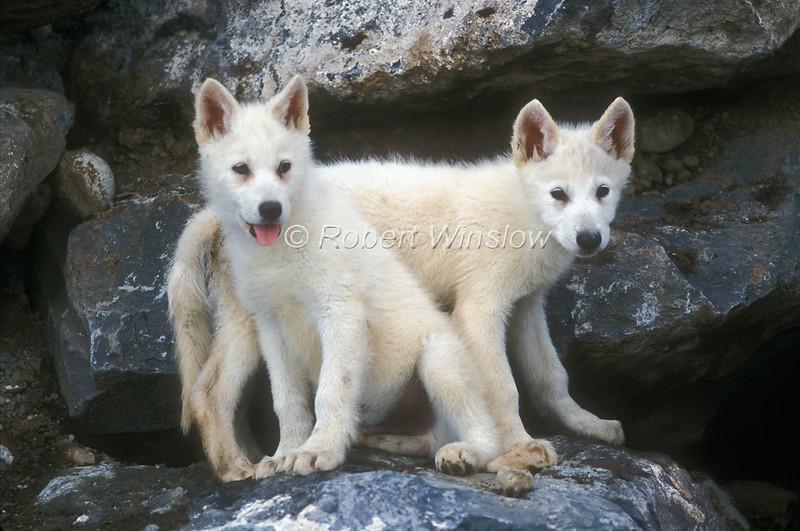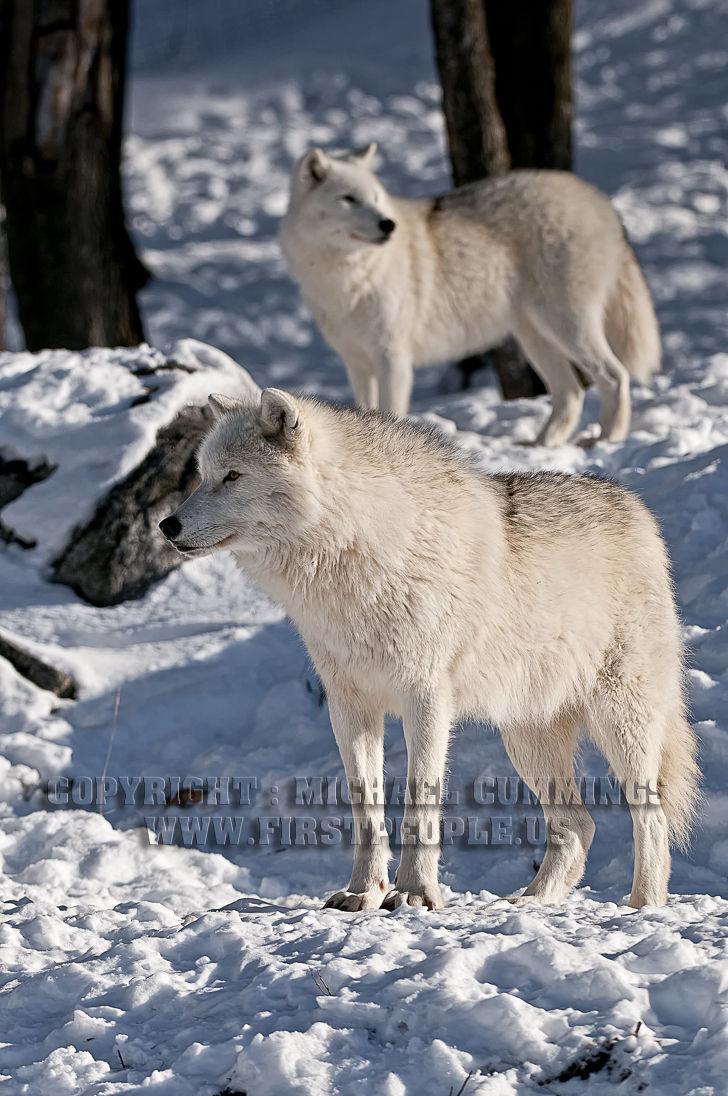The first image is the image on the left, the second image is the image on the right. For the images displayed, is the sentence "Each image contains two wolves, and one image shows the wolves standing on a boulder with tiers of boulders behind them." factually correct? Answer yes or no. Yes. The first image is the image on the left, the second image is the image on the right. For the images shown, is this caption "Two young white wolves are standing on a boulder." true? Answer yes or no. Yes. 